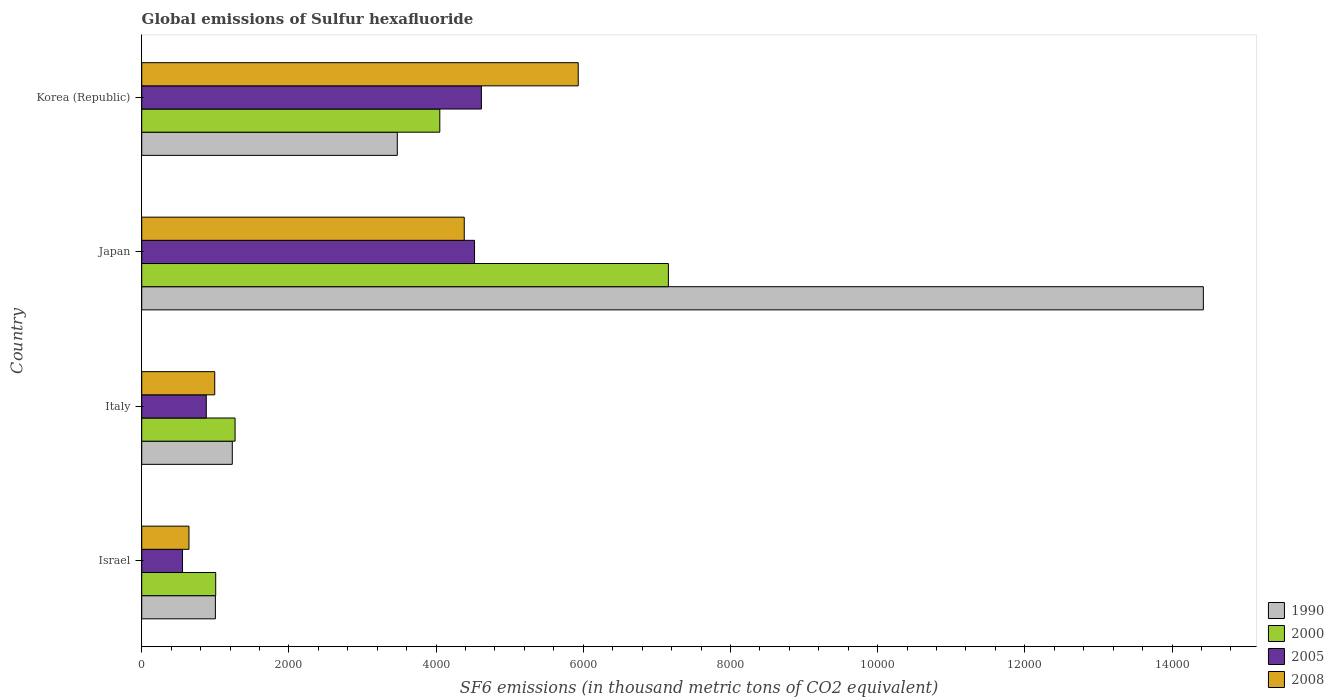How many different coloured bars are there?
Offer a terse response. 4. Are the number of bars on each tick of the Y-axis equal?
Your response must be concise. Yes. How many bars are there on the 3rd tick from the top?
Provide a short and direct response. 4. How many bars are there on the 4th tick from the bottom?
Your answer should be compact. 4. What is the label of the 2nd group of bars from the top?
Your response must be concise. Japan. In how many cases, is the number of bars for a given country not equal to the number of legend labels?
Your answer should be very brief. 0. What is the global emissions of Sulfur hexafluoride in 2000 in Korea (Republic)?
Your answer should be compact. 4050.5. Across all countries, what is the maximum global emissions of Sulfur hexafluoride in 2005?
Provide a succinct answer. 4615.7. Across all countries, what is the minimum global emissions of Sulfur hexafluoride in 2008?
Your answer should be compact. 642. In which country was the global emissions of Sulfur hexafluoride in 2008 minimum?
Your answer should be compact. Israel. What is the total global emissions of Sulfur hexafluoride in 2000 in the graph?
Give a very brief answer. 1.35e+04. What is the difference between the global emissions of Sulfur hexafluoride in 2005 in Israel and that in Japan?
Make the answer very short. -3968.6. What is the difference between the global emissions of Sulfur hexafluoride in 2008 in Israel and the global emissions of Sulfur hexafluoride in 2000 in Korea (Republic)?
Offer a very short reply. -3408.5. What is the average global emissions of Sulfur hexafluoride in 2000 per country?
Your answer should be very brief. 3370.2. What is the difference between the global emissions of Sulfur hexafluoride in 2008 and global emissions of Sulfur hexafluoride in 2005 in Korea (Republic)?
Your answer should be compact. 1315.9. In how many countries, is the global emissions of Sulfur hexafluoride in 1990 greater than 13600 thousand metric tons?
Provide a succinct answer. 1. What is the ratio of the global emissions of Sulfur hexafluoride in 2008 in Israel to that in Italy?
Offer a terse response. 0.65. Is the difference between the global emissions of Sulfur hexafluoride in 2008 in Israel and Japan greater than the difference between the global emissions of Sulfur hexafluoride in 2005 in Israel and Japan?
Keep it short and to the point. Yes. What is the difference between the highest and the second highest global emissions of Sulfur hexafluoride in 2008?
Your answer should be compact. 1548.9. What is the difference between the highest and the lowest global emissions of Sulfur hexafluoride in 2008?
Your answer should be compact. 5289.6. In how many countries, is the global emissions of Sulfur hexafluoride in 2005 greater than the average global emissions of Sulfur hexafluoride in 2005 taken over all countries?
Ensure brevity in your answer.  2. Is it the case that in every country, the sum of the global emissions of Sulfur hexafluoride in 2008 and global emissions of Sulfur hexafluoride in 2005 is greater than the sum of global emissions of Sulfur hexafluoride in 2000 and global emissions of Sulfur hexafluoride in 1990?
Your response must be concise. No. What does the 2nd bar from the bottom in Israel represents?
Offer a terse response. 2000. Are all the bars in the graph horizontal?
Make the answer very short. Yes. Does the graph contain any zero values?
Make the answer very short. No. Does the graph contain grids?
Provide a succinct answer. No. Where does the legend appear in the graph?
Your answer should be compact. Bottom right. How many legend labels are there?
Your answer should be very brief. 4. How are the legend labels stacked?
Your response must be concise. Vertical. What is the title of the graph?
Your response must be concise. Global emissions of Sulfur hexafluoride. What is the label or title of the X-axis?
Your response must be concise. SF6 emissions (in thousand metric tons of CO2 equivalent). What is the SF6 emissions (in thousand metric tons of CO2 equivalent) of 1990 in Israel?
Offer a very short reply. 1001. What is the SF6 emissions (in thousand metric tons of CO2 equivalent) of 2000 in Israel?
Your answer should be very brief. 1005.2. What is the SF6 emissions (in thousand metric tons of CO2 equivalent) in 2005 in Israel?
Make the answer very short. 553.7. What is the SF6 emissions (in thousand metric tons of CO2 equivalent) in 2008 in Israel?
Offer a terse response. 642. What is the SF6 emissions (in thousand metric tons of CO2 equivalent) in 1990 in Italy?
Ensure brevity in your answer.  1230.8. What is the SF6 emissions (in thousand metric tons of CO2 equivalent) in 2000 in Italy?
Keep it short and to the point. 1268.5. What is the SF6 emissions (in thousand metric tons of CO2 equivalent) of 2005 in Italy?
Offer a terse response. 877.2. What is the SF6 emissions (in thousand metric tons of CO2 equivalent) in 2008 in Italy?
Ensure brevity in your answer.  992.1. What is the SF6 emissions (in thousand metric tons of CO2 equivalent) of 1990 in Japan?
Offer a very short reply. 1.44e+04. What is the SF6 emissions (in thousand metric tons of CO2 equivalent) in 2000 in Japan?
Provide a short and direct response. 7156.6. What is the SF6 emissions (in thousand metric tons of CO2 equivalent) in 2005 in Japan?
Provide a short and direct response. 4522.3. What is the SF6 emissions (in thousand metric tons of CO2 equivalent) in 2008 in Japan?
Your answer should be compact. 4382.7. What is the SF6 emissions (in thousand metric tons of CO2 equivalent) of 1990 in Korea (Republic)?
Provide a short and direct response. 3472.9. What is the SF6 emissions (in thousand metric tons of CO2 equivalent) of 2000 in Korea (Republic)?
Offer a very short reply. 4050.5. What is the SF6 emissions (in thousand metric tons of CO2 equivalent) in 2005 in Korea (Republic)?
Offer a terse response. 4615.7. What is the SF6 emissions (in thousand metric tons of CO2 equivalent) of 2008 in Korea (Republic)?
Make the answer very short. 5931.6. Across all countries, what is the maximum SF6 emissions (in thousand metric tons of CO2 equivalent) in 1990?
Your answer should be compact. 1.44e+04. Across all countries, what is the maximum SF6 emissions (in thousand metric tons of CO2 equivalent) of 2000?
Your answer should be very brief. 7156.6. Across all countries, what is the maximum SF6 emissions (in thousand metric tons of CO2 equivalent) in 2005?
Keep it short and to the point. 4615.7. Across all countries, what is the maximum SF6 emissions (in thousand metric tons of CO2 equivalent) of 2008?
Offer a terse response. 5931.6. Across all countries, what is the minimum SF6 emissions (in thousand metric tons of CO2 equivalent) of 1990?
Ensure brevity in your answer.  1001. Across all countries, what is the minimum SF6 emissions (in thousand metric tons of CO2 equivalent) of 2000?
Provide a succinct answer. 1005.2. Across all countries, what is the minimum SF6 emissions (in thousand metric tons of CO2 equivalent) in 2005?
Your response must be concise. 553.7. Across all countries, what is the minimum SF6 emissions (in thousand metric tons of CO2 equivalent) in 2008?
Give a very brief answer. 642. What is the total SF6 emissions (in thousand metric tons of CO2 equivalent) of 1990 in the graph?
Provide a short and direct response. 2.01e+04. What is the total SF6 emissions (in thousand metric tons of CO2 equivalent) in 2000 in the graph?
Your answer should be compact. 1.35e+04. What is the total SF6 emissions (in thousand metric tons of CO2 equivalent) in 2005 in the graph?
Ensure brevity in your answer.  1.06e+04. What is the total SF6 emissions (in thousand metric tons of CO2 equivalent) in 2008 in the graph?
Your response must be concise. 1.19e+04. What is the difference between the SF6 emissions (in thousand metric tons of CO2 equivalent) in 1990 in Israel and that in Italy?
Make the answer very short. -229.8. What is the difference between the SF6 emissions (in thousand metric tons of CO2 equivalent) in 2000 in Israel and that in Italy?
Your answer should be compact. -263.3. What is the difference between the SF6 emissions (in thousand metric tons of CO2 equivalent) in 2005 in Israel and that in Italy?
Provide a succinct answer. -323.5. What is the difference between the SF6 emissions (in thousand metric tons of CO2 equivalent) of 2008 in Israel and that in Italy?
Offer a terse response. -350.1. What is the difference between the SF6 emissions (in thousand metric tons of CO2 equivalent) of 1990 in Israel and that in Japan?
Keep it short and to the point. -1.34e+04. What is the difference between the SF6 emissions (in thousand metric tons of CO2 equivalent) in 2000 in Israel and that in Japan?
Your answer should be compact. -6151.4. What is the difference between the SF6 emissions (in thousand metric tons of CO2 equivalent) in 2005 in Israel and that in Japan?
Ensure brevity in your answer.  -3968.6. What is the difference between the SF6 emissions (in thousand metric tons of CO2 equivalent) in 2008 in Israel and that in Japan?
Your answer should be compact. -3740.7. What is the difference between the SF6 emissions (in thousand metric tons of CO2 equivalent) of 1990 in Israel and that in Korea (Republic)?
Offer a very short reply. -2471.9. What is the difference between the SF6 emissions (in thousand metric tons of CO2 equivalent) of 2000 in Israel and that in Korea (Republic)?
Your answer should be compact. -3045.3. What is the difference between the SF6 emissions (in thousand metric tons of CO2 equivalent) of 2005 in Israel and that in Korea (Republic)?
Give a very brief answer. -4062. What is the difference between the SF6 emissions (in thousand metric tons of CO2 equivalent) in 2008 in Israel and that in Korea (Republic)?
Ensure brevity in your answer.  -5289.6. What is the difference between the SF6 emissions (in thousand metric tons of CO2 equivalent) of 1990 in Italy and that in Japan?
Your answer should be compact. -1.32e+04. What is the difference between the SF6 emissions (in thousand metric tons of CO2 equivalent) in 2000 in Italy and that in Japan?
Offer a very short reply. -5888.1. What is the difference between the SF6 emissions (in thousand metric tons of CO2 equivalent) of 2005 in Italy and that in Japan?
Provide a succinct answer. -3645.1. What is the difference between the SF6 emissions (in thousand metric tons of CO2 equivalent) of 2008 in Italy and that in Japan?
Give a very brief answer. -3390.6. What is the difference between the SF6 emissions (in thousand metric tons of CO2 equivalent) in 1990 in Italy and that in Korea (Republic)?
Your answer should be very brief. -2242.1. What is the difference between the SF6 emissions (in thousand metric tons of CO2 equivalent) in 2000 in Italy and that in Korea (Republic)?
Give a very brief answer. -2782. What is the difference between the SF6 emissions (in thousand metric tons of CO2 equivalent) of 2005 in Italy and that in Korea (Republic)?
Offer a terse response. -3738.5. What is the difference between the SF6 emissions (in thousand metric tons of CO2 equivalent) of 2008 in Italy and that in Korea (Republic)?
Provide a succinct answer. -4939.5. What is the difference between the SF6 emissions (in thousand metric tons of CO2 equivalent) of 1990 in Japan and that in Korea (Republic)?
Provide a succinct answer. 1.10e+04. What is the difference between the SF6 emissions (in thousand metric tons of CO2 equivalent) of 2000 in Japan and that in Korea (Republic)?
Provide a short and direct response. 3106.1. What is the difference between the SF6 emissions (in thousand metric tons of CO2 equivalent) in 2005 in Japan and that in Korea (Republic)?
Give a very brief answer. -93.4. What is the difference between the SF6 emissions (in thousand metric tons of CO2 equivalent) of 2008 in Japan and that in Korea (Republic)?
Keep it short and to the point. -1548.9. What is the difference between the SF6 emissions (in thousand metric tons of CO2 equivalent) of 1990 in Israel and the SF6 emissions (in thousand metric tons of CO2 equivalent) of 2000 in Italy?
Provide a short and direct response. -267.5. What is the difference between the SF6 emissions (in thousand metric tons of CO2 equivalent) of 1990 in Israel and the SF6 emissions (in thousand metric tons of CO2 equivalent) of 2005 in Italy?
Your response must be concise. 123.8. What is the difference between the SF6 emissions (in thousand metric tons of CO2 equivalent) of 1990 in Israel and the SF6 emissions (in thousand metric tons of CO2 equivalent) of 2008 in Italy?
Offer a terse response. 8.9. What is the difference between the SF6 emissions (in thousand metric tons of CO2 equivalent) in 2000 in Israel and the SF6 emissions (in thousand metric tons of CO2 equivalent) in 2005 in Italy?
Offer a terse response. 128. What is the difference between the SF6 emissions (in thousand metric tons of CO2 equivalent) in 2005 in Israel and the SF6 emissions (in thousand metric tons of CO2 equivalent) in 2008 in Italy?
Make the answer very short. -438.4. What is the difference between the SF6 emissions (in thousand metric tons of CO2 equivalent) of 1990 in Israel and the SF6 emissions (in thousand metric tons of CO2 equivalent) of 2000 in Japan?
Keep it short and to the point. -6155.6. What is the difference between the SF6 emissions (in thousand metric tons of CO2 equivalent) in 1990 in Israel and the SF6 emissions (in thousand metric tons of CO2 equivalent) in 2005 in Japan?
Offer a terse response. -3521.3. What is the difference between the SF6 emissions (in thousand metric tons of CO2 equivalent) of 1990 in Israel and the SF6 emissions (in thousand metric tons of CO2 equivalent) of 2008 in Japan?
Ensure brevity in your answer.  -3381.7. What is the difference between the SF6 emissions (in thousand metric tons of CO2 equivalent) in 2000 in Israel and the SF6 emissions (in thousand metric tons of CO2 equivalent) in 2005 in Japan?
Ensure brevity in your answer.  -3517.1. What is the difference between the SF6 emissions (in thousand metric tons of CO2 equivalent) of 2000 in Israel and the SF6 emissions (in thousand metric tons of CO2 equivalent) of 2008 in Japan?
Keep it short and to the point. -3377.5. What is the difference between the SF6 emissions (in thousand metric tons of CO2 equivalent) in 2005 in Israel and the SF6 emissions (in thousand metric tons of CO2 equivalent) in 2008 in Japan?
Your answer should be compact. -3829. What is the difference between the SF6 emissions (in thousand metric tons of CO2 equivalent) of 1990 in Israel and the SF6 emissions (in thousand metric tons of CO2 equivalent) of 2000 in Korea (Republic)?
Provide a short and direct response. -3049.5. What is the difference between the SF6 emissions (in thousand metric tons of CO2 equivalent) in 1990 in Israel and the SF6 emissions (in thousand metric tons of CO2 equivalent) in 2005 in Korea (Republic)?
Provide a short and direct response. -3614.7. What is the difference between the SF6 emissions (in thousand metric tons of CO2 equivalent) in 1990 in Israel and the SF6 emissions (in thousand metric tons of CO2 equivalent) in 2008 in Korea (Republic)?
Provide a short and direct response. -4930.6. What is the difference between the SF6 emissions (in thousand metric tons of CO2 equivalent) in 2000 in Israel and the SF6 emissions (in thousand metric tons of CO2 equivalent) in 2005 in Korea (Republic)?
Ensure brevity in your answer.  -3610.5. What is the difference between the SF6 emissions (in thousand metric tons of CO2 equivalent) in 2000 in Israel and the SF6 emissions (in thousand metric tons of CO2 equivalent) in 2008 in Korea (Republic)?
Keep it short and to the point. -4926.4. What is the difference between the SF6 emissions (in thousand metric tons of CO2 equivalent) in 2005 in Israel and the SF6 emissions (in thousand metric tons of CO2 equivalent) in 2008 in Korea (Republic)?
Your answer should be very brief. -5377.9. What is the difference between the SF6 emissions (in thousand metric tons of CO2 equivalent) of 1990 in Italy and the SF6 emissions (in thousand metric tons of CO2 equivalent) of 2000 in Japan?
Give a very brief answer. -5925.8. What is the difference between the SF6 emissions (in thousand metric tons of CO2 equivalent) in 1990 in Italy and the SF6 emissions (in thousand metric tons of CO2 equivalent) in 2005 in Japan?
Keep it short and to the point. -3291.5. What is the difference between the SF6 emissions (in thousand metric tons of CO2 equivalent) of 1990 in Italy and the SF6 emissions (in thousand metric tons of CO2 equivalent) of 2008 in Japan?
Give a very brief answer. -3151.9. What is the difference between the SF6 emissions (in thousand metric tons of CO2 equivalent) in 2000 in Italy and the SF6 emissions (in thousand metric tons of CO2 equivalent) in 2005 in Japan?
Your response must be concise. -3253.8. What is the difference between the SF6 emissions (in thousand metric tons of CO2 equivalent) in 2000 in Italy and the SF6 emissions (in thousand metric tons of CO2 equivalent) in 2008 in Japan?
Provide a short and direct response. -3114.2. What is the difference between the SF6 emissions (in thousand metric tons of CO2 equivalent) in 2005 in Italy and the SF6 emissions (in thousand metric tons of CO2 equivalent) in 2008 in Japan?
Offer a very short reply. -3505.5. What is the difference between the SF6 emissions (in thousand metric tons of CO2 equivalent) of 1990 in Italy and the SF6 emissions (in thousand metric tons of CO2 equivalent) of 2000 in Korea (Republic)?
Ensure brevity in your answer.  -2819.7. What is the difference between the SF6 emissions (in thousand metric tons of CO2 equivalent) in 1990 in Italy and the SF6 emissions (in thousand metric tons of CO2 equivalent) in 2005 in Korea (Republic)?
Your answer should be very brief. -3384.9. What is the difference between the SF6 emissions (in thousand metric tons of CO2 equivalent) of 1990 in Italy and the SF6 emissions (in thousand metric tons of CO2 equivalent) of 2008 in Korea (Republic)?
Your answer should be compact. -4700.8. What is the difference between the SF6 emissions (in thousand metric tons of CO2 equivalent) in 2000 in Italy and the SF6 emissions (in thousand metric tons of CO2 equivalent) in 2005 in Korea (Republic)?
Offer a very short reply. -3347.2. What is the difference between the SF6 emissions (in thousand metric tons of CO2 equivalent) in 2000 in Italy and the SF6 emissions (in thousand metric tons of CO2 equivalent) in 2008 in Korea (Republic)?
Give a very brief answer. -4663.1. What is the difference between the SF6 emissions (in thousand metric tons of CO2 equivalent) of 2005 in Italy and the SF6 emissions (in thousand metric tons of CO2 equivalent) of 2008 in Korea (Republic)?
Offer a terse response. -5054.4. What is the difference between the SF6 emissions (in thousand metric tons of CO2 equivalent) of 1990 in Japan and the SF6 emissions (in thousand metric tons of CO2 equivalent) of 2000 in Korea (Republic)?
Your answer should be very brief. 1.04e+04. What is the difference between the SF6 emissions (in thousand metric tons of CO2 equivalent) in 1990 in Japan and the SF6 emissions (in thousand metric tons of CO2 equivalent) in 2005 in Korea (Republic)?
Give a very brief answer. 9810.1. What is the difference between the SF6 emissions (in thousand metric tons of CO2 equivalent) in 1990 in Japan and the SF6 emissions (in thousand metric tons of CO2 equivalent) in 2008 in Korea (Republic)?
Provide a succinct answer. 8494.2. What is the difference between the SF6 emissions (in thousand metric tons of CO2 equivalent) of 2000 in Japan and the SF6 emissions (in thousand metric tons of CO2 equivalent) of 2005 in Korea (Republic)?
Your response must be concise. 2540.9. What is the difference between the SF6 emissions (in thousand metric tons of CO2 equivalent) in 2000 in Japan and the SF6 emissions (in thousand metric tons of CO2 equivalent) in 2008 in Korea (Republic)?
Your answer should be compact. 1225. What is the difference between the SF6 emissions (in thousand metric tons of CO2 equivalent) of 2005 in Japan and the SF6 emissions (in thousand metric tons of CO2 equivalent) of 2008 in Korea (Republic)?
Ensure brevity in your answer.  -1409.3. What is the average SF6 emissions (in thousand metric tons of CO2 equivalent) of 1990 per country?
Ensure brevity in your answer.  5032.62. What is the average SF6 emissions (in thousand metric tons of CO2 equivalent) in 2000 per country?
Your response must be concise. 3370.2. What is the average SF6 emissions (in thousand metric tons of CO2 equivalent) in 2005 per country?
Provide a short and direct response. 2642.22. What is the average SF6 emissions (in thousand metric tons of CO2 equivalent) of 2008 per country?
Offer a very short reply. 2987.1. What is the difference between the SF6 emissions (in thousand metric tons of CO2 equivalent) in 1990 and SF6 emissions (in thousand metric tons of CO2 equivalent) in 2000 in Israel?
Your response must be concise. -4.2. What is the difference between the SF6 emissions (in thousand metric tons of CO2 equivalent) of 1990 and SF6 emissions (in thousand metric tons of CO2 equivalent) of 2005 in Israel?
Ensure brevity in your answer.  447.3. What is the difference between the SF6 emissions (in thousand metric tons of CO2 equivalent) in 1990 and SF6 emissions (in thousand metric tons of CO2 equivalent) in 2008 in Israel?
Make the answer very short. 359. What is the difference between the SF6 emissions (in thousand metric tons of CO2 equivalent) in 2000 and SF6 emissions (in thousand metric tons of CO2 equivalent) in 2005 in Israel?
Give a very brief answer. 451.5. What is the difference between the SF6 emissions (in thousand metric tons of CO2 equivalent) of 2000 and SF6 emissions (in thousand metric tons of CO2 equivalent) of 2008 in Israel?
Offer a very short reply. 363.2. What is the difference between the SF6 emissions (in thousand metric tons of CO2 equivalent) in 2005 and SF6 emissions (in thousand metric tons of CO2 equivalent) in 2008 in Israel?
Give a very brief answer. -88.3. What is the difference between the SF6 emissions (in thousand metric tons of CO2 equivalent) of 1990 and SF6 emissions (in thousand metric tons of CO2 equivalent) of 2000 in Italy?
Offer a very short reply. -37.7. What is the difference between the SF6 emissions (in thousand metric tons of CO2 equivalent) of 1990 and SF6 emissions (in thousand metric tons of CO2 equivalent) of 2005 in Italy?
Offer a very short reply. 353.6. What is the difference between the SF6 emissions (in thousand metric tons of CO2 equivalent) of 1990 and SF6 emissions (in thousand metric tons of CO2 equivalent) of 2008 in Italy?
Offer a terse response. 238.7. What is the difference between the SF6 emissions (in thousand metric tons of CO2 equivalent) of 2000 and SF6 emissions (in thousand metric tons of CO2 equivalent) of 2005 in Italy?
Keep it short and to the point. 391.3. What is the difference between the SF6 emissions (in thousand metric tons of CO2 equivalent) of 2000 and SF6 emissions (in thousand metric tons of CO2 equivalent) of 2008 in Italy?
Your response must be concise. 276.4. What is the difference between the SF6 emissions (in thousand metric tons of CO2 equivalent) of 2005 and SF6 emissions (in thousand metric tons of CO2 equivalent) of 2008 in Italy?
Your answer should be very brief. -114.9. What is the difference between the SF6 emissions (in thousand metric tons of CO2 equivalent) of 1990 and SF6 emissions (in thousand metric tons of CO2 equivalent) of 2000 in Japan?
Make the answer very short. 7269.2. What is the difference between the SF6 emissions (in thousand metric tons of CO2 equivalent) of 1990 and SF6 emissions (in thousand metric tons of CO2 equivalent) of 2005 in Japan?
Your response must be concise. 9903.5. What is the difference between the SF6 emissions (in thousand metric tons of CO2 equivalent) in 1990 and SF6 emissions (in thousand metric tons of CO2 equivalent) in 2008 in Japan?
Your answer should be very brief. 1.00e+04. What is the difference between the SF6 emissions (in thousand metric tons of CO2 equivalent) in 2000 and SF6 emissions (in thousand metric tons of CO2 equivalent) in 2005 in Japan?
Provide a succinct answer. 2634.3. What is the difference between the SF6 emissions (in thousand metric tons of CO2 equivalent) in 2000 and SF6 emissions (in thousand metric tons of CO2 equivalent) in 2008 in Japan?
Ensure brevity in your answer.  2773.9. What is the difference between the SF6 emissions (in thousand metric tons of CO2 equivalent) in 2005 and SF6 emissions (in thousand metric tons of CO2 equivalent) in 2008 in Japan?
Your response must be concise. 139.6. What is the difference between the SF6 emissions (in thousand metric tons of CO2 equivalent) in 1990 and SF6 emissions (in thousand metric tons of CO2 equivalent) in 2000 in Korea (Republic)?
Provide a succinct answer. -577.6. What is the difference between the SF6 emissions (in thousand metric tons of CO2 equivalent) in 1990 and SF6 emissions (in thousand metric tons of CO2 equivalent) in 2005 in Korea (Republic)?
Keep it short and to the point. -1142.8. What is the difference between the SF6 emissions (in thousand metric tons of CO2 equivalent) in 1990 and SF6 emissions (in thousand metric tons of CO2 equivalent) in 2008 in Korea (Republic)?
Your answer should be very brief. -2458.7. What is the difference between the SF6 emissions (in thousand metric tons of CO2 equivalent) in 2000 and SF6 emissions (in thousand metric tons of CO2 equivalent) in 2005 in Korea (Republic)?
Keep it short and to the point. -565.2. What is the difference between the SF6 emissions (in thousand metric tons of CO2 equivalent) in 2000 and SF6 emissions (in thousand metric tons of CO2 equivalent) in 2008 in Korea (Republic)?
Your response must be concise. -1881.1. What is the difference between the SF6 emissions (in thousand metric tons of CO2 equivalent) in 2005 and SF6 emissions (in thousand metric tons of CO2 equivalent) in 2008 in Korea (Republic)?
Your answer should be compact. -1315.9. What is the ratio of the SF6 emissions (in thousand metric tons of CO2 equivalent) in 1990 in Israel to that in Italy?
Your response must be concise. 0.81. What is the ratio of the SF6 emissions (in thousand metric tons of CO2 equivalent) in 2000 in Israel to that in Italy?
Provide a succinct answer. 0.79. What is the ratio of the SF6 emissions (in thousand metric tons of CO2 equivalent) in 2005 in Israel to that in Italy?
Offer a terse response. 0.63. What is the ratio of the SF6 emissions (in thousand metric tons of CO2 equivalent) of 2008 in Israel to that in Italy?
Ensure brevity in your answer.  0.65. What is the ratio of the SF6 emissions (in thousand metric tons of CO2 equivalent) in 1990 in Israel to that in Japan?
Provide a succinct answer. 0.07. What is the ratio of the SF6 emissions (in thousand metric tons of CO2 equivalent) of 2000 in Israel to that in Japan?
Provide a short and direct response. 0.14. What is the ratio of the SF6 emissions (in thousand metric tons of CO2 equivalent) of 2005 in Israel to that in Japan?
Offer a terse response. 0.12. What is the ratio of the SF6 emissions (in thousand metric tons of CO2 equivalent) in 2008 in Israel to that in Japan?
Make the answer very short. 0.15. What is the ratio of the SF6 emissions (in thousand metric tons of CO2 equivalent) in 1990 in Israel to that in Korea (Republic)?
Offer a terse response. 0.29. What is the ratio of the SF6 emissions (in thousand metric tons of CO2 equivalent) of 2000 in Israel to that in Korea (Republic)?
Give a very brief answer. 0.25. What is the ratio of the SF6 emissions (in thousand metric tons of CO2 equivalent) in 2005 in Israel to that in Korea (Republic)?
Provide a succinct answer. 0.12. What is the ratio of the SF6 emissions (in thousand metric tons of CO2 equivalent) in 2008 in Israel to that in Korea (Republic)?
Keep it short and to the point. 0.11. What is the ratio of the SF6 emissions (in thousand metric tons of CO2 equivalent) of 1990 in Italy to that in Japan?
Your response must be concise. 0.09. What is the ratio of the SF6 emissions (in thousand metric tons of CO2 equivalent) of 2000 in Italy to that in Japan?
Provide a succinct answer. 0.18. What is the ratio of the SF6 emissions (in thousand metric tons of CO2 equivalent) of 2005 in Italy to that in Japan?
Your answer should be very brief. 0.19. What is the ratio of the SF6 emissions (in thousand metric tons of CO2 equivalent) in 2008 in Italy to that in Japan?
Provide a short and direct response. 0.23. What is the ratio of the SF6 emissions (in thousand metric tons of CO2 equivalent) of 1990 in Italy to that in Korea (Republic)?
Your answer should be very brief. 0.35. What is the ratio of the SF6 emissions (in thousand metric tons of CO2 equivalent) of 2000 in Italy to that in Korea (Republic)?
Keep it short and to the point. 0.31. What is the ratio of the SF6 emissions (in thousand metric tons of CO2 equivalent) of 2005 in Italy to that in Korea (Republic)?
Ensure brevity in your answer.  0.19. What is the ratio of the SF6 emissions (in thousand metric tons of CO2 equivalent) of 2008 in Italy to that in Korea (Republic)?
Give a very brief answer. 0.17. What is the ratio of the SF6 emissions (in thousand metric tons of CO2 equivalent) of 1990 in Japan to that in Korea (Republic)?
Your answer should be compact. 4.15. What is the ratio of the SF6 emissions (in thousand metric tons of CO2 equivalent) of 2000 in Japan to that in Korea (Republic)?
Make the answer very short. 1.77. What is the ratio of the SF6 emissions (in thousand metric tons of CO2 equivalent) of 2005 in Japan to that in Korea (Republic)?
Make the answer very short. 0.98. What is the ratio of the SF6 emissions (in thousand metric tons of CO2 equivalent) of 2008 in Japan to that in Korea (Republic)?
Ensure brevity in your answer.  0.74. What is the difference between the highest and the second highest SF6 emissions (in thousand metric tons of CO2 equivalent) in 1990?
Make the answer very short. 1.10e+04. What is the difference between the highest and the second highest SF6 emissions (in thousand metric tons of CO2 equivalent) of 2000?
Offer a very short reply. 3106.1. What is the difference between the highest and the second highest SF6 emissions (in thousand metric tons of CO2 equivalent) of 2005?
Keep it short and to the point. 93.4. What is the difference between the highest and the second highest SF6 emissions (in thousand metric tons of CO2 equivalent) in 2008?
Give a very brief answer. 1548.9. What is the difference between the highest and the lowest SF6 emissions (in thousand metric tons of CO2 equivalent) in 1990?
Your answer should be very brief. 1.34e+04. What is the difference between the highest and the lowest SF6 emissions (in thousand metric tons of CO2 equivalent) in 2000?
Offer a terse response. 6151.4. What is the difference between the highest and the lowest SF6 emissions (in thousand metric tons of CO2 equivalent) in 2005?
Your answer should be very brief. 4062. What is the difference between the highest and the lowest SF6 emissions (in thousand metric tons of CO2 equivalent) of 2008?
Provide a succinct answer. 5289.6. 